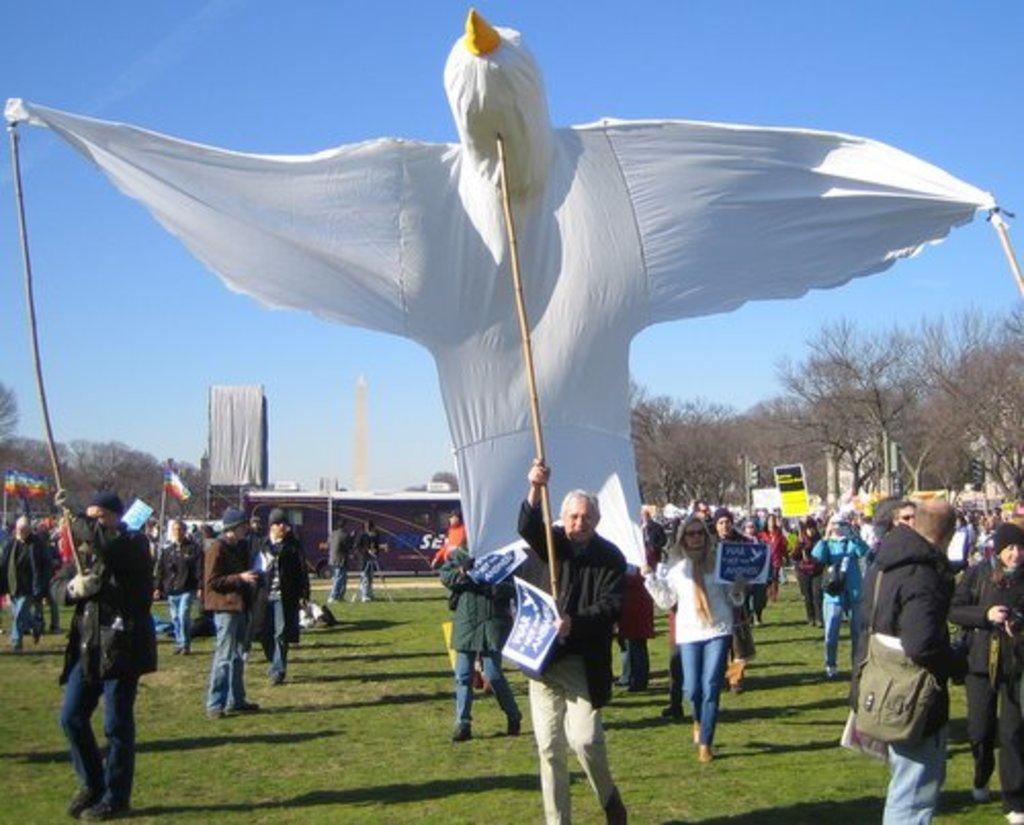In one or two sentences, can you explain what this image depicts? In this image we can see a few people, two of them are holding sticks, those sticks are tied to a cloth, there are some people holding placards with text on them, some of them are wearing bags, there are trees, tower, shed, also we can see the sky. 